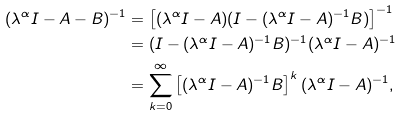Convert formula to latex. <formula><loc_0><loc_0><loc_500><loc_500>( \lambda ^ { \alpha } I - A - B ) ^ { - 1 } & = \left [ ( \lambda ^ { \alpha } I - A ) ( I - ( \lambda ^ { \alpha } I - A ) ^ { - 1 } B ) \right ] ^ { - 1 } \\ & = ( I - ( \lambda ^ { \alpha } I - A ) ^ { - 1 } B ) ^ { - 1 } ( \lambda ^ { \alpha } I - A ) ^ { - 1 } \\ & = \sum _ { k = 0 } ^ { \infty } \left [ ( \lambda ^ { \alpha } I - A ) ^ { - 1 } B \right ] ^ { k } ( \lambda ^ { \alpha } I - A ) ^ { - 1 } ,</formula> 